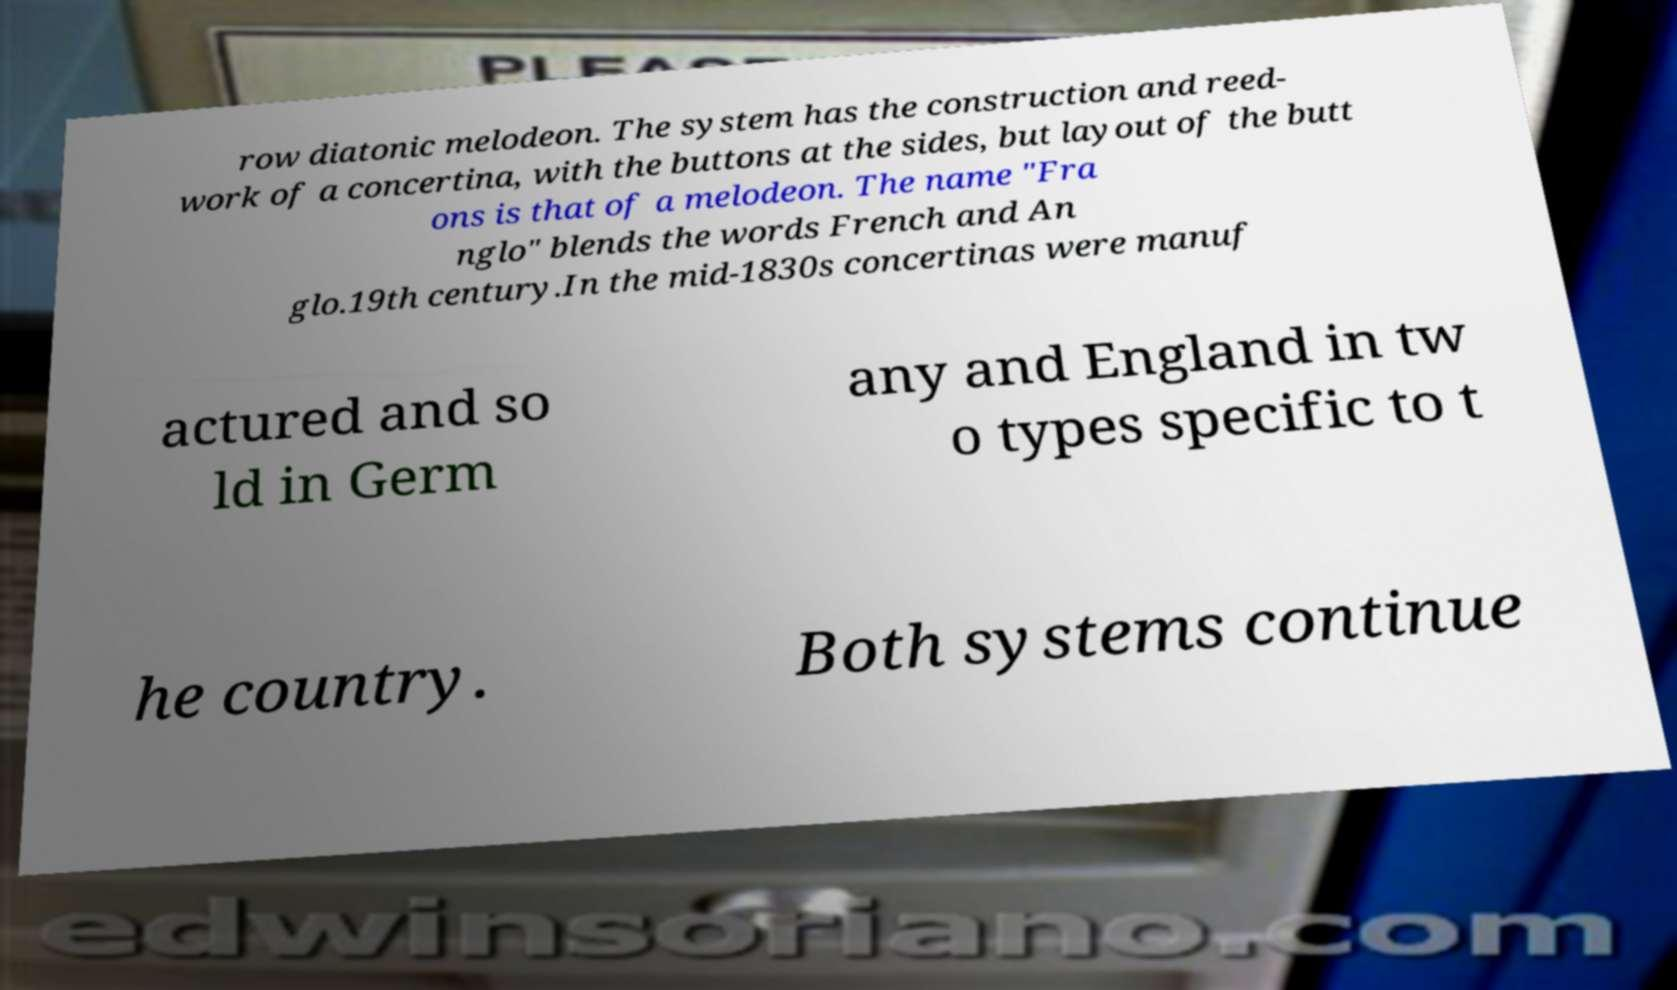What messages or text are displayed in this image? I need them in a readable, typed format. row diatonic melodeon. The system has the construction and reed- work of a concertina, with the buttons at the sides, but layout of the butt ons is that of a melodeon. The name "Fra nglo" blends the words French and An glo.19th century.In the mid-1830s concertinas were manuf actured and so ld in Germ any and England in tw o types specific to t he country. Both systems continue 